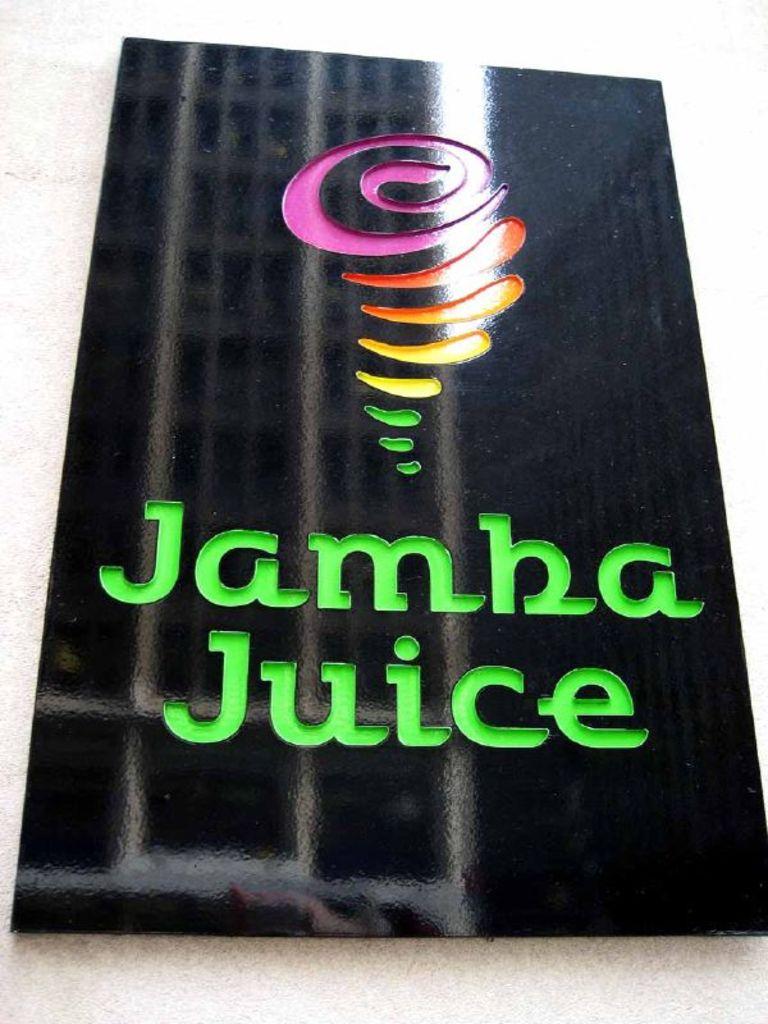What juice shop is mentioned?
Your response must be concise. Jamba juice. 